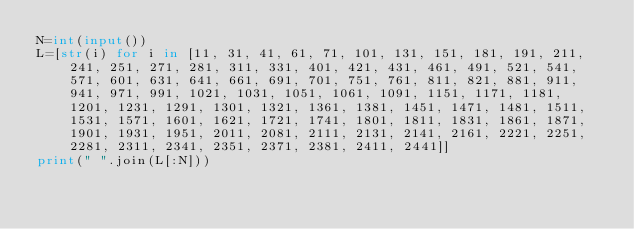<code> <loc_0><loc_0><loc_500><loc_500><_Python_>N=int(input())
L=[str(i) for i in [11, 31, 41, 61, 71, 101, 131, 151, 181, 191, 211, 241, 251, 271, 281, 311, 331, 401, 421, 431, 461, 491, 521, 541, 571, 601, 631, 641, 661, 691, 701, 751, 761, 811, 821, 881, 911, 941, 971, 991, 1021, 1031, 1051, 1061, 1091, 1151, 1171, 1181, 1201, 1231, 1291, 1301, 1321, 1361, 1381, 1451, 1471, 1481, 1511, 1531, 1571, 1601, 1621, 1721, 1741, 1801, 1811, 1831, 1861, 1871, 1901, 1931, 1951, 2011, 2081, 2111, 2131, 2141, 2161, 2221, 2251, 2281, 2311, 2341, 2351, 2371, 2381, 2411, 2441]]
print(" ".join(L[:N]))
</code> 